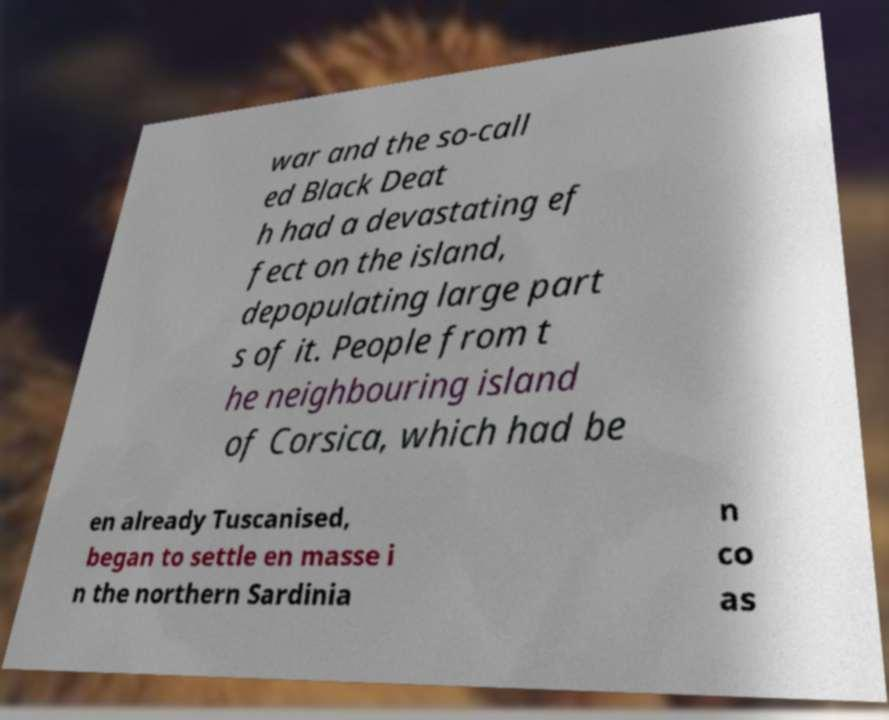Could you assist in decoding the text presented in this image and type it out clearly? war and the so-call ed Black Deat h had a devastating ef fect on the island, depopulating large part s of it. People from t he neighbouring island of Corsica, which had be en already Tuscanised, began to settle en masse i n the northern Sardinia n co as 